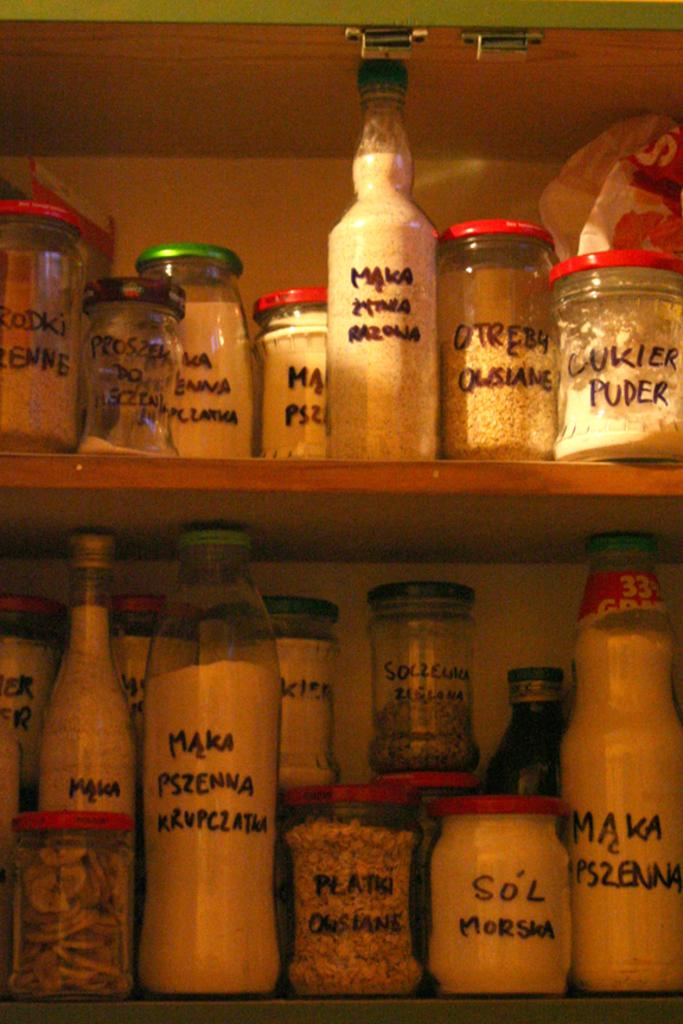<image>
Render a clear and concise summary of the photo. Jars filled with things like Lukier Puder line some pantry shelves. 